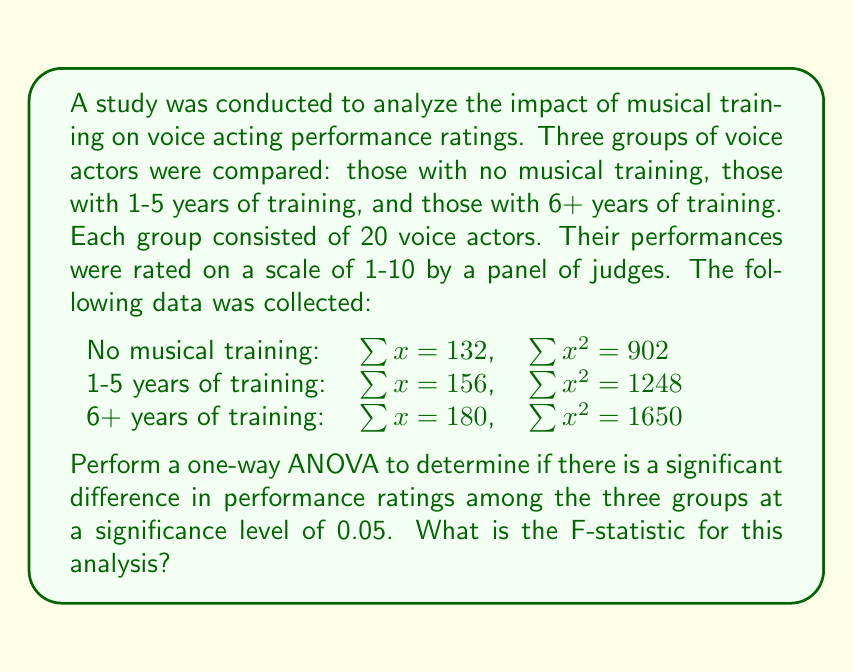Can you solve this math problem? To perform a one-way ANOVA, we need to follow these steps:

1. Calculate the total sum of squares (SST)
2. Calculate the between-group sum of squares (SSB)
3. Calculate the within-group sum of squares (SSW)
4. Calculate the degrees of freedom
5. Calculate the mean squares
6. Calculate the F-statistic

Step 1: Calculate SST
First, we need to find the grand mean:
$$\bar{x} = \frac{132 + 156 + 180}{60} = 7.8$$

Then, we calculate SST:
$$SST = (902 + 1248 + 1650) - \frac{(132 + 156 + 180)^2}{60} = 3800 - 3648 = 152$$

Step 2: Calculate SSB
We need to calculate the group means:
$$\bar{x}_1 = \frac{132}{20} = 6.6$$
$$\bar{x}_2 = \frac{156}{20} = 7.8$$
$$\bar{x}_3 = \frac{180}{20} = 9.0$$

Now we can calculate SSB:
$$SSB = 20[(6.6 - 7.8)^2 + (7.8 - 7.8)^2 + (9.0 - 7.8)^2] = 72$$

Step 3: Calculate SSW
$$SSW = SST - SSB = 152 - 72 = 80$$

Step 4: Calculate degrees of freedom
Between-group df: $k - 1 = 3 - 1 = 2$
Within-group df: $N - k = 60 - 3 = 57$
Total df: $N - 1 = 60 - 1 = 59$

Step 5: Calculate mean squares
$$MSB = \frac{SSB}{df_b} = \frac{72}{2} = 36$$
$$MSW = \frac{SSW}{df_w} = \frac{80}{57} \approx 1.4035$$

Step 6: Calculate F-statistic
$$F = \frac{MSB}{MSW} = \frac{36}{1.4035} \approx 25.65$$
Answer: The F-statistic for this analysis is approximately 25.65. 